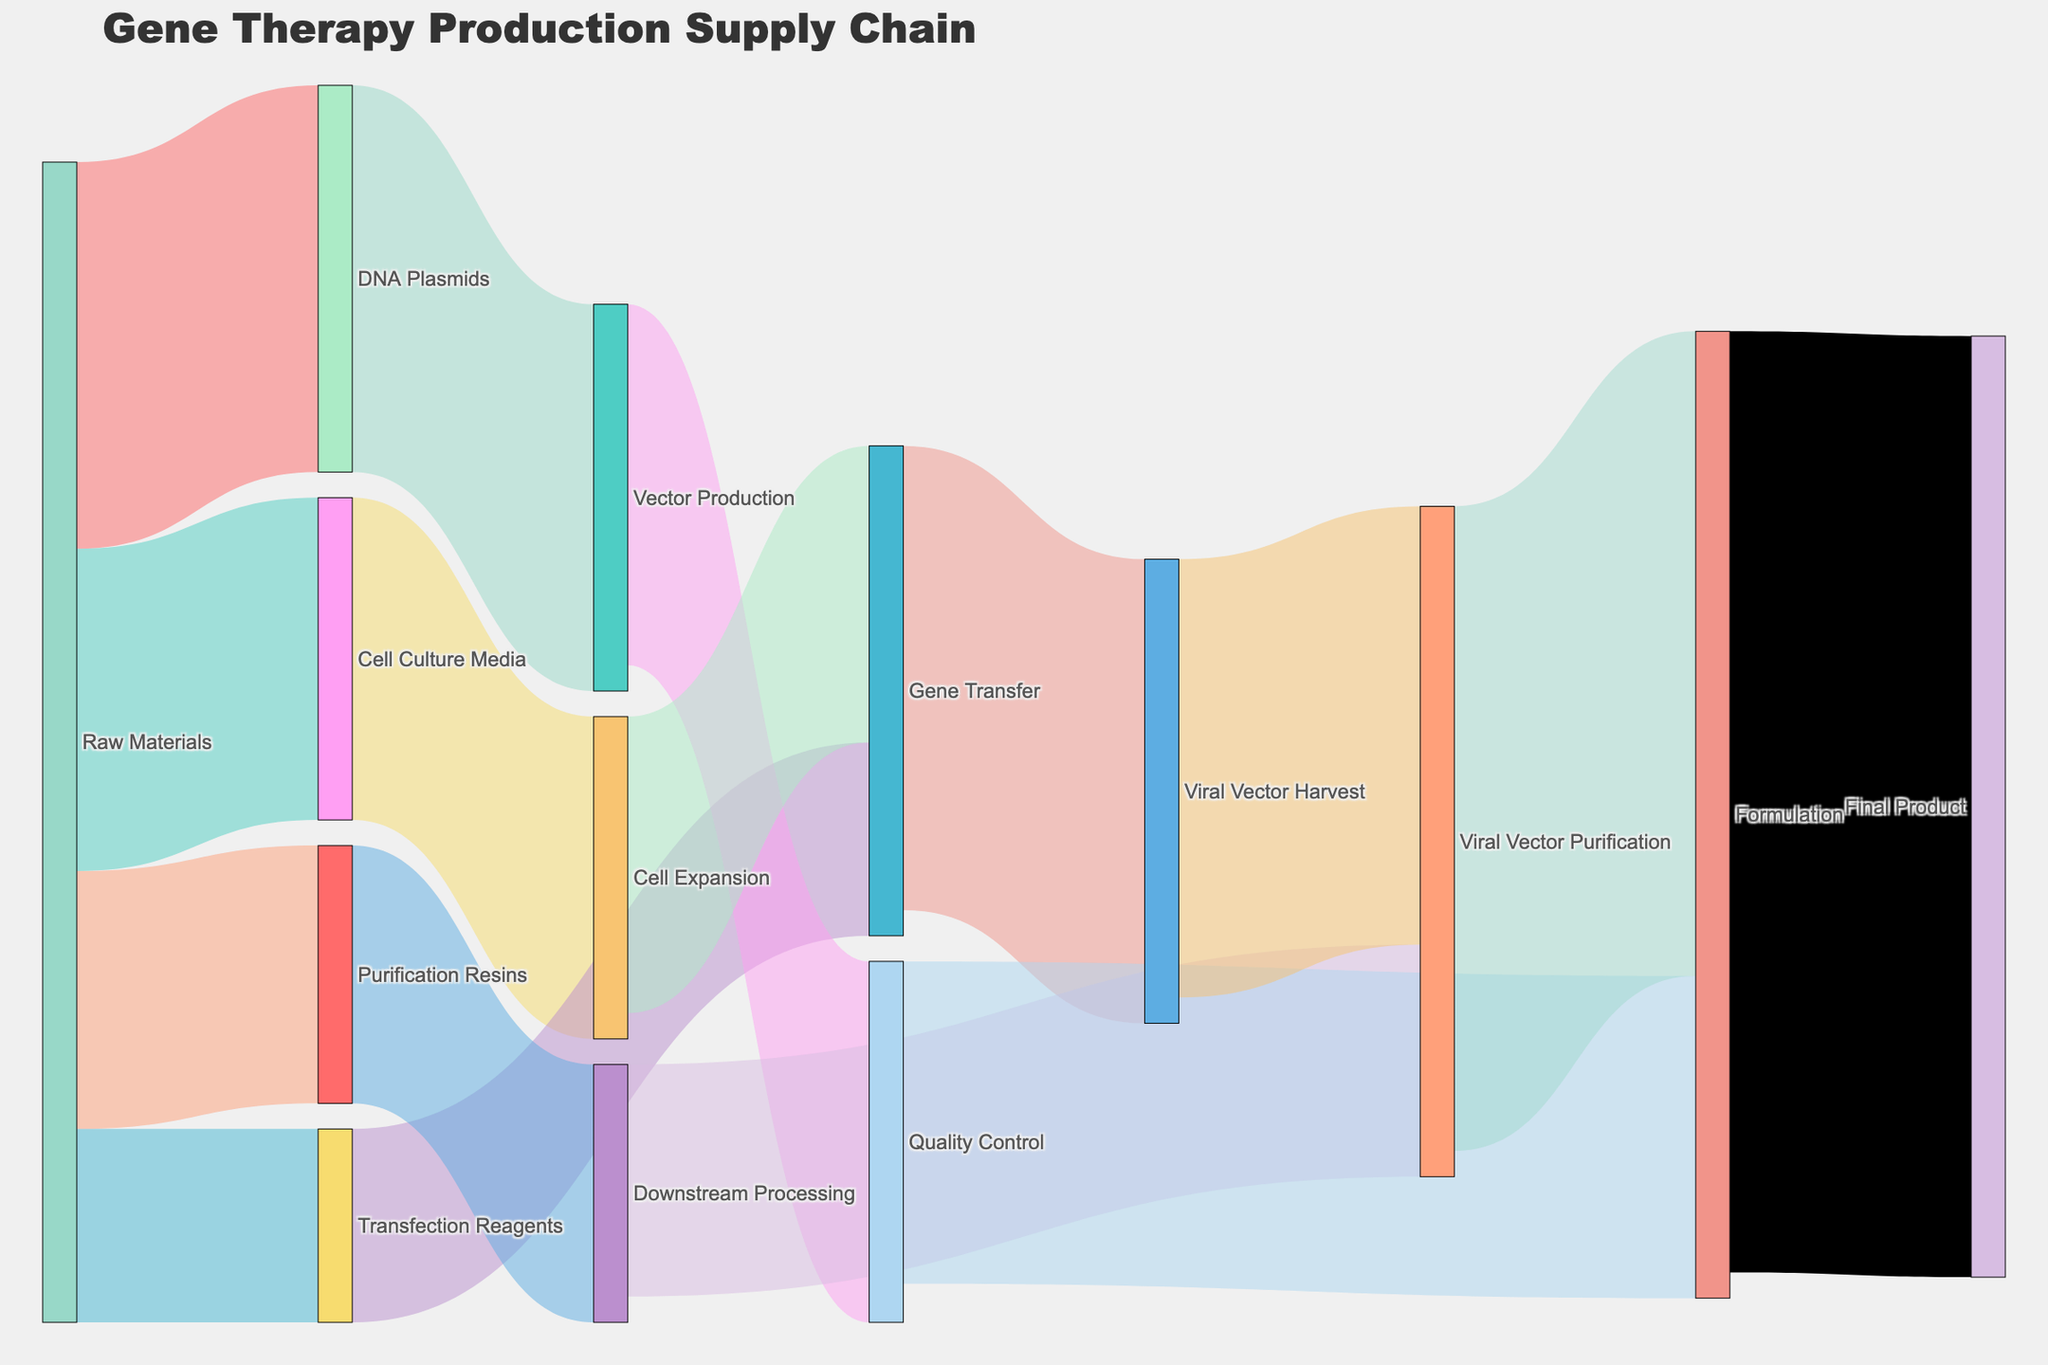Which stage receives the most flow from Viral Vector Purification? The Final Product stage receives the highest flow from Viral Vector Purification. This can be determined by observing which target node has the largest link value originating from Viral Vector Purification.
Answer: Final Product How many different stages does Raw Materials supply to? Raw Materials supply to four different stages: DNA Plasmids, Cell Culture Media, Transfection Reagents, and Purification Resins. This can be seen by counting the distinct target nodes connected to Raw Materials.
Answer: Four What is the total flow going into the Formulation stage? The total flow into the Formulation stage can be calculated by summing the values coming from Quality Control and Viral Vector Purification. The values are 25 and 50 respectively, so the total is 25 + 50.
Answer: 75 Which stage has the highest value flow going out of it? By comparing the values of the outbound links from each stage, we see that the stage with the highest outbound value flow is Formulation with a value of 73 going to the Final Product.
Answer: Formulation Between Cell Expansion and Gene Transfer, which one has a higher inbound flow value? To determine this, compare the inbound link values. Cell Expansion has an inbound value from Cell Culture Media of 25, and Gene Transfer has an inbound value from Transfection Reagents of 15 and Cell Expansion of 23. Summing Gene Transfer's values gives 15 + 23 = 38. Thus, Gene Transfer has a higher inbound flow value.
Answer: Gene Transfer How is the flow from Transfection Reagents distributed? The entire flow from Transfection Reagents, which is 15, goes to Gene Transfer. This can be determined by looking at the link value connecting Transfection Reagents and Gene Transfer.
Answer: 100% to Gene Transfer What is the total value of the flows that involve Vector Production as either source or target? To find this value, sum all the flows where Vector Production is either a source or target: from DNA Plasmids (30), to Quality Control (28). Thus, the total is 30 + 28.
Answer: 58 What proportion of the flow from Raw Materials goes into Purification Resins? The value from Raw Materials to Purification Resins is 20. The total flow from Raw Materials is 30+25+15+20 = 90. The proportion is calculated by 20/90.
Answer: 22.22% Compare the flows into Quality Control and Downstream Processing and determine which one has the higher flow. Quality Control has an inbound flow of 28 from Vector Production, while Downstream Processing has an inbound flow of 20 from Purification Resins. Thus, Quality Control has the higher flow.
Answer: Quality Control What is the ratio of the flow going into the Final Product from Formulation compared to the flow going into Viral Vector Purification from Gene Transfer? The inbound flow to the Final Product from Formulation is 73, and the inbound flow to Viral Vector Purification from Gene Transfer is 36. The ratio is 73/36.
Answer: 2.03 